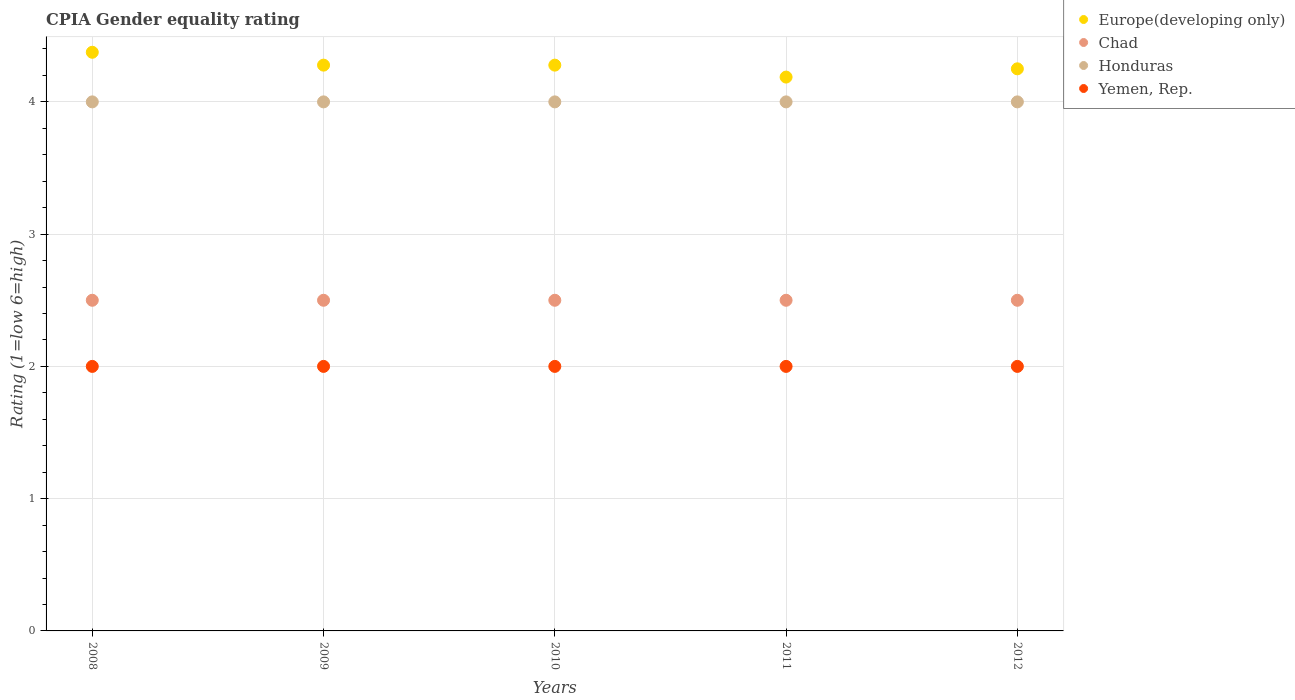How many different coloured dotlines are there?
Your answer should be very brief. 4. Is the number of dotlines equal to the number of legend labels?
Offer a very short reply. Yes. What is the CPIA rating in Europe(developing only) in 2008?
Keep it short and to the point. 4.38. Across all years, what is the minimum CPIA rating in Europe(developing only)?
Offer a terse response. 4.19. In which year was the CPIA rating in Yemen, Rep. maximum?
Your answer should be very brief. 2008. In which year was the CPIA rating in Europe(developing only) minimum?
Your response must be concise. 2011. What is the total CPIA rating in Honduras in the graph?
Provide a short and direct response. 20. What is the difference between the CPIA rating in Chad in 2011 and the CPIA rating in Honduras in 2010?
Provide a succinct answer. -1.5. In the year 2009, what is the difference between the CPIA rating in Honduras and CPIA rating in Europe(developing only)?
Your response must be concise. -0.28. Is the CPIA rating in Chad in 2008 less than that in 2011?
Provide a succinct answer. No. Is the difference between the CPIA rating in Honduras in 2009 and 2011 greater than the difference between the CPIA rating in Europe(developing only) in 2009 and 2011?
Provide a succinct answer. No. What is the difference between the highest and the second highest CPIA rating in Europe(developing only)?
Ensure brevity in your answer.  0.1. What is the difference between the highest and the lowest CPIA rating in Yemen, Rep.?
Offer a terse response. 0. Is the sum of the CPIA rating in Chad in 2009 and 2012 greater than the maximum CPIA rating in Honduras across all years?
Your answer should be very brief. Yes. Is it the case that in every year, the sum of the CPIA rating in Yemen, Rep. and CPIA rating in Europe(developing only)  is greater than the sum of CPIA rating in Honduras and CPIA rating in Chad?
Your answer should be very brief. No. Is it the case that in every year, the sum of the CPIA rating in Yemen, Rep. and CPIA rating in Europe(developing only)  is greater than the CPIA rating in Honduras?
Provide a short and direct response. Yes. Is the CPIA rating in Chad strictly less than the CPIA rating in Honduras over the years?
Your answer should be very brief. Yes. How many dotlines are there?
Your answer should be very brief. 4. What is the difference between two consecutive major ticks on the Y-axis?
Your answer should be very brief. 1. Does the graph contain grids?
Your response must be concise. Yes. How are the legend labels stacked?
Provide a succinct answer. Vertical. What is the title of the graph?
Offer a terse response. CPIA Gender equality rating. Does "Latvia" appear as one of the legend labels in the graph?
Make the answer very short. No. What is the Rating (1=low 6=high) in Europe(developing only) in 2008?
Keep it short and to the point. 4.38. What is the Rating (1=low 6=high) of Honduras in 2008?
Your answer should be very brief. 4. What is the Rating (1=low 6=high) of Europe(developing only) in 2009?
Offer a very short reply. 4.28. What is the Rating (1=low 6=high) of Chad in 2009?
Provide a short and direct response. 2.5. What is the Rating (1=low 6=high) in Europe(developing only) in 2010?
Your answer should be compact. 4.28. What is the Rating (1=low 6=high) in Chad in 2010?
Your response must be concise. 2.5. What is the Rating (1=low 6=high) in Honduras in 2010?
Ensure brevity in your answer.  4. What is the Rating (1=low 6=high) in Yemen, Rep. in 2010?
Provide a succinct answer. 2. What is the Rating (1=low 6=high) in Europe(developing only) in 2011?
Provide a succinct answer. 4.19. What is the Rating (1=low 6=high) in Chad in 2011?
Provide a short and direct response. 2.5. What is the Rating (1=low 6=high) in Honduras in 2011?
Provide a succinct answer. 4. What is the Rating (1=low 6=high) in Europe(developing only) in 2012?
Offer a very short reply. 4.25. What is the Rating (1=low 6=high) of Honduras in 2012?
Ensure brevity in your answer.  4. What is the Rating (1=low 6=high) of Yemen, Rep. in 2012?
Offer a terse response. 2. Across all years, what is the maximum Rating (1=low 6=high) in Europe(developing only)?
Your response must be concise. 4.38. Across all years, what is the maximum Rating (1=low 6=high) in Chad?
Give a very brief answer. 2.5. Across all years, what is the maximum Rating (1=low 6=high) in Yemen, Rep.?
Ensure brevity in your answer.  2. Across all years, what is the minimum Rating (1=low 6=high) in Europe(developing only)?
Your answer should be compact. 4.19. Across all years, what is the minimum Rating (1=low 6=high) of Chad?
Your answer should be very brief. 2.5. Across all years, what is the minimum Rating (1=low 6=high) in Honduras?
Your response must be concise. 4. Across all years, what is the minimum Rating (1=low 6=high) of Yemen, Rep.?
Provide a short and direct response. 2. What is the total Rating (1=low 6=high) in Europe(developing only) in the graph?
Offer a very short reply. 21.37. What is the total Rating (1=low 6=high) of Chad in the graph?
Provide a short and direct response. 12.5. What is the total Rating (1=low 6=high) of Honduras in the graph?
Offer a terse response. 20. What is the total Rating (1=low 6=high) of Yemen, Rep. in the graph?
Keep it short and to the point. 10. What is the difference between the Rating (1=low 6=high) in Europe(developing only) in 2008 and that in 2009?
Ensure brevity in your answer.  0.1. What is the difference between the Rating (1=low 6=high) in Chad in 2008 and that in 2009?
Keep it short and to the point. 0. What is the difference between the Rating (1=low 6=high) in Europe(developing only) in 2008 and that in 2010?
Your answer should be very brief. 0.1. What is the difference between the Rating (1=low 6=high) in Honduras in 2008 and that in 2010?
Provide a short and direct response. 0. What is the difference between the Rating (1=low 6=high) of Europe(developing only) in 2008 and that in 2011?
Your response must be concise. 0.19. What is the difference between the Rating (1=low 6=high) of Chad in 2008 and that in 2011?
Make the answer very short. 0. What is the difference between the Rating (1=low 6=high) of Europe(developing only) in 2008 and that in 2012?
Offer a very short reply. 0.12. What is the difference between the Rating (1=low 6=high) in Honduras in 2008 and that in 2012?
Your response must be concise. 0. What is the difference between the Rating (1=low 6=high) of Yemen, Rep. in 2008 and that in 2012?
Make the answer very short. 0. What is the difference between the Rating (1=low 6=high) in Chad in 2009 and that in 2010?
Offer a very short reply. 0. What is the difference between the Rating (1=low 6=high) of Honduras in 2009 and that in 2010?
Provide a short and direct response. 0. What is the difference between the Rating (1=low 6=high) of Europe(developing only) in 2009 and that in 2011?
Offer a very short reply. 0.09. What is the difference between the Rating (1=low 6=high) in Chad in 2009 and that in 2011?
Give a very brief answer. 0. What is the difference between the Rating (1=low 6=high) of Europe(developing only) in 2009 and that in 2012?
Your answer should be very brief. 0.03. What is the difference between the Rating (1=low 6=high) in Chad in 2009 and that in 2012?
Keep it short and to the point. 0. What is the difference between the Rating (1=low 6=high) in Europe(developing only) in 2010 and that in 2011?
Your response must be concise. 0.09. What is the difference between the Rating (1=low 6=high) in Honduras in 2010 and that in 2011?
Offer a terse response. 0. What is the difference between the Rating (1=low 6=high) of Europe(developing only) in 2010 and that in 2012?
Make the answer very short. 0.03. What is the difference between the Rating (1=low 6=high) of Honduras in 2010 and that in 2012?
Make the answer very short. 0. What is the difference between the Rating (1=low 6=high) in Yemen, Rep. in 2010 and that in 2012?
Provide a succinct answer. 0. What is the difference between the Rating (1=low 6=high) of Europe(developing only) in 2011 and that in 2012?
Provide a short and direct response. -0.06. What is the difference between the Rating (1=low 6=high) in Chad in 2011 and that in 2012?
Your response must be concise. 0. What is the difference between the Rating (1=low 6=high) in Yemen, Rep. in 2011 and that in 2012?
Your response must be concise. 0. What is the difference between the Rating (1=low 6=high) of Europe(developing only) in 2008 and the Rating (1=low 6=high) of Chad in 2009?
Provide a succinct answer. 1.88. What is the difference between the Rating (1=low 6=high) of Europe(developing only) in 2008 and the Rating (1=low 6=high) of Yemen, Rep. in 2009?
Ensure brevity in your answer.  2.38. What is the difference between the Rating (1=low 6=high) in Chad in 2008 and the Rating (1=low 6=high) in Honduras in 2009?
Ensure brevity in your answer.  -1.5. What is the difference between the Rating (1=low 6=high) in Chad in 2008 and the Rating (1=low 6=high) in Yemen, Rep. in 2009?
Your response must be concise. 0.5. What is the difference between the Rating (1=low 6=high) in Europe(developing only) in 2008 and the Rating (1=low 6=high) in Chad in 2010?
Your response must be concise. 1.88. What is the difference between the Rating (1=low 6=high) in Europe(developing only) in 2008 and the Rating (1=low 6=high) in Honduras in 2010?
Ensure brevity in your answer.  0.38. What is the difference between the Rating (1=low 6=high) of Europe(developing only) in 2008 and the Rating (1=low 6=high) of Yemen, Rep. in 2010?
Ensure brevity in your answer.  2.38. What is the difference between the Rating (1=low 6=high) in Chad in 2008 and the Rating (1=low 6=high) in Honduras in 2010?
Give a very brief answer. -1.5. What is the difference between the Rating (1=low 6=high) in Chad in 2008 and the Rating (1=low 6=high) in Yemen, Rep. in 2010?
Make the answer very short. 0.5. What is the difference between the Rating (1=low 6=high) in Europe(developing only) in 2008 and the Rating (1=low 6=high) in Chad in 2011?
Your answer should be compact. 1.88. What is the difference between the Rating (1=low 6=high) of Europe(developing only) in 2008 and the Rating (1=low 6=high) of Yemen, Rep. in 2011?
Ensure brevity in your answer.  2.38. What is the difference between the Rating (1=low 6=high) of Chad in 2008 and the Rating (1=low 6=high) of Yemen, Rep. in 2011?
Your answer should be compact. 0.5. What is the difference between the Rating (1=low 6=high) of Honduras in 2008 and the Rating (1=low 6=high) of Yemen, Rep. in 2011?
Your answer should be compact. 2. What is the difference between the Rating (1=low 6=high) in Europe(developing only) in 2008 and the Rating (1=low 6=high) in Chad in 2012?
Your answer should be compact. 1.88. What is the difference between the Rating (1=low 6=high) in Europe(developing only) in 2008 and the Rating (1=low 6=high) in Honduras in 2012?
Ensure brevity in your answer.  0.38. What is the difference between the Rating (1=low 6=high) of Europe(developing only) in 2008 and the Rating (1=low 6=high) of Yemen, Rep. in 2012?
Ensure brevity in your answer.  2.38. What is the difference between the Rating (1=low 6=high) in Chad in 2008 and the Rating (1=low 6=high) in Honduras in 2012?
Give a very brief answer. -1.5. What is the difference between the Rating (1=low 6=high) in Chad in 2008 and the Rating (1=low 6=high) in Yemen, Rep. in 2012?
Offer a terse response. 0.5. What is the difference between the Rating (1=low 6=high) in Honduras in 2008 and the Rating (1=low 6=high) in Yemen, Rep. in 2012?
Offer a terse response. 2. What is the difference between the Rating (1=low 6=high) in Europe(developing only) in 2009 and the Rating (1=low 6=high) in Chad in 2010?
Give a very brief answer. 1.78. What is the difference between the Rating (1=low 6=high) in Europe(developing only) in 2009 and the Rating (1=low 6=high) in Honduras in 2010?
Make the answer very short. 0.28. What is the difference between the Rating (1=low 6=high) of Europe(developing only) in 2009 and the Rating (1=low 6=high) of Yemen, Rep. in 2010?
Your answer should be very brief. 2.28. What is the difference between the Rating (1=low 6=high) of Europe(developing only) in 2009 and the Rating (1=low 6=high) of Chad in 2011?
Provide a succinct answer. 1.78. What is the difference between the Rating (1=low 6=high) of Europe(developing only) in 2009 and the Rating (1=low 6=high) of Honduras in 2011?
Ensure brevity in your answer.  0.28. What is the difference between the Rating (1=low 6=high) of Europe(developing only) in 2009 and the Rating (1=low 6=high) of Yemen, Rep. in 2011?
Give a very brief answer. 2.28. What is the difference between the Rating (1=low 6=high) of Chad in 2009 and the Rating (1=low 6=high) of Honduras in 2011?
Ensure brevity in your answer.  -1.5. What is the difference between the Rating (1=low 6=high) in Chad in 2009 and the Rating (1=low 6=high) in Yemen, Rep. in 2011?
Offer a terse response. 0.5. What is the difference between the Rating (1=low 6=high) in Honduras in 2009 and the Rating (1=low 6=high) in Yemen, Rep. in 2011?
Provide a short and direct response. 2. What is the difference between the Rating (1=low 6=high) in Europe(developing only) in 2009 and the Rating (1=low 6=high) in Chad in 2012?
Make the answer very short. 1.78. What is the difference between the Rating (1=low 6=high) in Europe(developing only) in 2009 and the Rating (1=low 6=high) in Honduras in 2012?
Make the answer very short. 0.28. What is the difference between the Rating (1=low 6=high) of Europe(developing only) in 2009 and the Rating (1=low 6=high) of Yemen, Rep. in 2012?
Give a very brief answer. 2.28. What is the difference between the Rating (1=low 6=high) of Europe(developing only) in 2010 and the Rating (1=low 6=high) of Chad in 2011?
Make the answer very short. 1.78. What is the difference between the Rating (1=low 6=high) of Europe(developing only) in 2010 and the Rating (1=low 6=high) of Honduras in 2011?
Provide a short and direct response. 0.28. What is the difference between the Rating (1=low 6=high) in Europe(developing only) in 2010 and the Rating (1=low 6=high) in Yemen, Rep. in 2011?
Give a very brief answer. 2.28. What is the difference between the Rating (1=low 6=high) in Chad in 2010 and the Rating (1=low 6=high) in Yemen, Rep. in 2011?
Provide a short and direct response. 0.5. What is the difference between the Rating (1=low 6=high) in Europe(developing only) in 2010 and the Rating (1=low 6=high) in Chad in 2012?
Your answer should be compact. 1.78. What is the difference between the Rating (1=low 6=high) of Europe(developing only) in 2010 and the Rating (1=low 6=high) of Honduras in 2012?
Ensure brevity in your answer.  0.28. What is the difference between the Rating (1=low 6=high) of Europe(developing only) in 2010 and the Rating (1=low 6=high) of Yemen, Rep. in 2012?
Make the answer very short. 2.28. What is the difference between the Rating (1=low 6=high) of Chad in 2010 and the Rating (1=low 6=high) of Honduras in 2012?
Keep it short and to the point. -1.5. What is the difference between the Rating (1=low 6=high) in Honduras in 2010 and the Rating (1=low 6=high) in Yemen, Rep. in 2012?
Provide a succinct answer. 2. What is the difference between the Rating (1=low 6=high) of Europe(developing only) in 2011 and the Rating (1=low 6=high) of Chad in 2012?
Offer a terse response. 1.69. What is the difference between the Rating (1=low 6=high) in Europe(developing only) in 2011 and the Rating (1=low 6=high) in Honduras in 2012?
Make the answer very short. 0.19. What is the difference between the Rating (1=low 6=high) of Europe(developing only) in 2011 and the Rating (1=low 6=high) of Yemen, Rep. in 2012?
Give a very brief answer. 2.19. What is the difference between the Rating (1=low 6=high) of Chad in 2011 and the Rating (1=low 6=high) of Yemen, Rep. in 2012?
Your answer should be compact. 0.5. What is the difference between the Rating (1=low 6=high) of Honduras in 2011 and the Rating (1=low 6=high) of Yemen, Rep. in 2012?
Provide a short and direct response. 2. What is the average Rating (1=low 6=high) in Europe(developing only) per year?
Give a very brief answer. 4.27. In the year 2008, what is the difference between the Rating (1=low 6=high) of Europe(developing only) and Rating (1=low 6=high) of Chad?
Your answer should be compact. 1.88. In the year 2008, what is the difference between the Rating (1=low 6=high) in Europe(developing only) and Rating (1=low 6=high) in Yemen, Rep.?
Provide a succinct answer. 2.38. In the year 2008, what is the difference between the Rating (1=low 6=high) of Honduras and Rating (1=low 6=high) of Yemen, Rep.?
Keep it short and to the point. 2. In the year 2009, what is the difference between the Rating (1=low 6=high) in Europe(developing only) and Rating (1=low 6=high) in Chad?
Give a very brief answer. 1.78. In the year 2009, what is the difference between the Rating (1=low 6=high) of Europe(developing only) and Rating (1=low 6=high) of Honduras?
Your answer should be compact. 0.28. In the year 2009, what is the difference between the Rating (1=low 6=high) of Europe(developing only) and Rating (1=low 6=high) of Yemen, Rep.?
Give a very brief answer. 2.28. In the year 2009, what is the difference between the Rating (1=low 6=high) of Honduras and Rating (1=low 6=high) of Yemen, Rep.?
Offer a very short reply. 2. In the year 2010, what is the difference between the Rating (1=low 6=high) of Europe(developing only) and Rating (1=low 6=high) of Chad?
Ensure brevity in your answer.  1.78. In the year 2010, what is the difference between the Rating (1=low 6=high) in Europe(developing only) and Rating (1=low 6=high) in Honduras?
Your response must be concise. 0.28. In the year 2010, what is the difference between the Rating (1=low 6=high) in Europe(developing only) and Rating (1=low 6=high) in Yemen, Rep.?
Provide a succinct answer. 2.28. In the year 2010, what is the difference between the Rating (1=low 6=high) in Chad and Rating (1=low 6=high) in Honduras?
Offer a terse response. -1.5. In the year 2010, what is the difference between the Rating (1=low 6=high) of Chad and Rating (1=low 6=high) of Yemen, Rep.?
Your answer should be very brief. 0.5. In the year 2010, what is the difference between the Rating (1=low 6=high) in Honduras and Rating (1=low 6=high) in Yemen, Rep.?
Ensure brevity in your answer.  2. In the year 2011, what is the difference between the Rating (1=low 6=high) in Europe(developing only) and Rating (1=low 6=high) in Chad?
Provide a succinct answer. 1.69. In the year 2011, what is the difference between the Rating (1=low 6=high) in Europe(developing only) and Rating (1=low 6=high) in Honduras?
Offer a terse response. 0.19. In the year 2011, what is the difference between the Rating (1=low 6=high) in Europe(developing only) and Rating (1=low 6=high) in Yemen, Rep.?
Keep it short and to the point. 2.19. In the year 2011, what is the difference between the Rating (1=low 6=high) of Chad and Rating (1=low 6=high) of Honduras?
Offer a very short reply. -1.5. In the year 2011, what is the difference between the Rating (1=low 6=high) of Chad and Rating (1=low 6=high) of Yemen, Rep.?
Offer a very short reply. 0.5. In the year 2011, what is the difference between the Rating (1=low 6=high) in Honduras and Rating (1=low 6=high) in Yemen, Rep.?
Offer a terse response. 2. In the year 2012, what is the difference between the Rating (1=low 6=high) of Europe(developing only) and Rating (1=low 6=high) of Yemen, Rep.?
Keep it short and to the point. 2.25. In the year 2012, what is the difference between the Rating (1=low 6=high) in Honduras and Rating (1=low 6=high) in Yemen, Rep.?
Your answer should be compact. 2. What is the ratio of the Rating (1=low 6=high) in Europe(developing only) in 2008 to that in 2009?
Ensure brevity in your answer.  1.02. What is the ratio of the Rating (1=low 6=high) in Chad in 2008 to that in 2009?
Your answer should be very brief. 1. What is the ratio of the Rating (1=low 6=high) of Europe(developing only) in 2008 to that in 2010?
Your answer should be compact. 1.02. What is the ratio of the Rating (1=low 6=high) in Chad in 2008 to that in 2010?
Offer a terse response. 1. What is the ratio of the Rating (1=low 6=high) in Europe(developing only) in 2008 to that in 2011?
Your answer should be very brief. 1.04. What is the ratio of the Rating (1=low 6=high) in Honduras in 2008 to that in 2011?
Give a very brief answer. 1. What is the ratio of the Rating (1=low 6=high) in Yemen, Rep. in 2008 to that in 2011?
Make the answer very short. 1. What is the ratio of the Rating (1=low 6=high) of Europe(developing only) in 2008 to that in 2012?
Your answer should be compact. 1.03. What is the ratio of the Rating (1=low 6=high) in Europe(developing only) in 2009 to that in 2011?
Provide a short and direct response. 1.02. What is the ratio of the Rating (1=low 6=high) of Chad in 2009 to that in 2011?
Offer a terse response. 1. What is the ratio of the Rating (1=low 6=high) of Honduras in 2009 to that in 2011?
Ensure brevity in your answer.  1. What is the ratio of the Rating (1=low 6=high) in Europe(developing only) in 2009 to that in 2012?
Make the answer very short. 1.01. What is the ratio of the Rating (1=low 6=high) of Chad in 2009 to that in 2012?
Offer a very short reply. 1. What is the ratio of the Rating (1=low 6=high) in Europe(developing only) in 2010 to that in 2011?
Ensure brevity in your answer.  1.02. What is the ratio of the Rating (1=low 6=high) in Chad in 2010 to that in 2011?
Offer a terse response. 1. What is the ratio of the Rating (1=low 6=high) of Honduras in 2010 to that in 2011?
Ensure brevity in your answer.  1. What is the ratio of the Rating (1=low 6=high) in Yemen, Rep. in 2010 to that in 2011?
Your response must be concise. 1. What is the ratio of the Rating (1=low 6=high) of Chad in 2010 to that in 2012?
Offer a terse response. 1. What is the ratio of the Rating (1=low 6=high) in Honduras in 2010 to that in 2012?
Your answer should be very brief. 1. What is the ratio of the Rating (1=low 6=high) of Yemen, Rep. in 2010 to that in 2012?
Offer a terse response. 1. What is the difference between the highest and the second highest Rating (1=low 6=high) of Europe(developing only)?
Offer a very short reply. 0.1. What is the difference between the highest and the lowest Rating (1=low 6=high) in Europe(developing only)?
Your response must be concise. 0.19. 